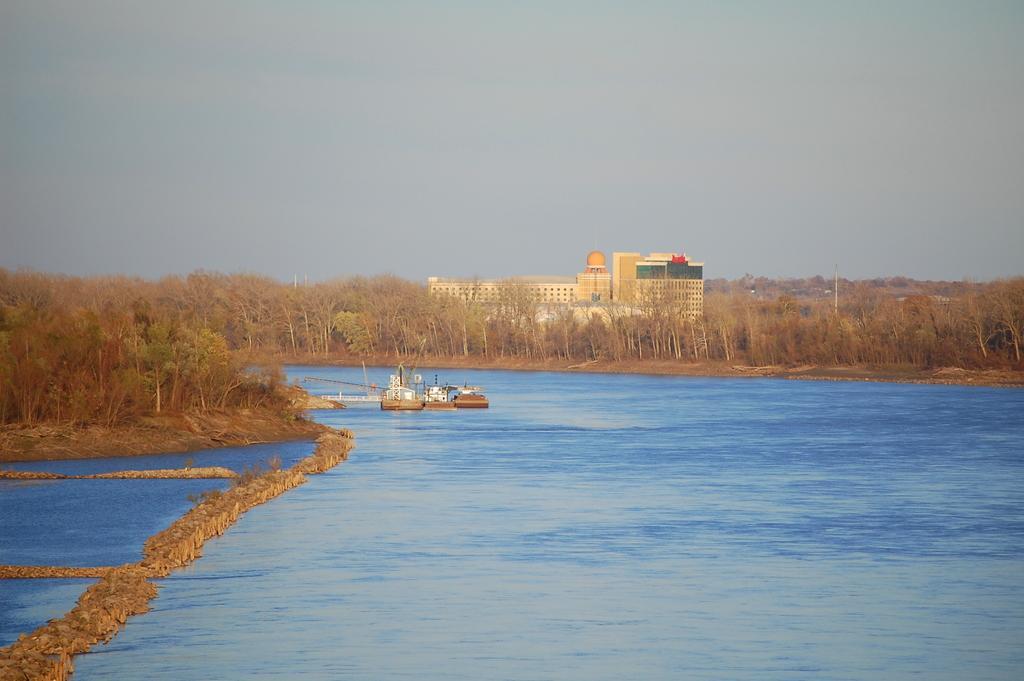In one or two sentences, can you explain what this image depicts? In this picture, we can see building with windows, ground, grass, plants, trees, we can see water, boats, and we can see pole and the sky. 